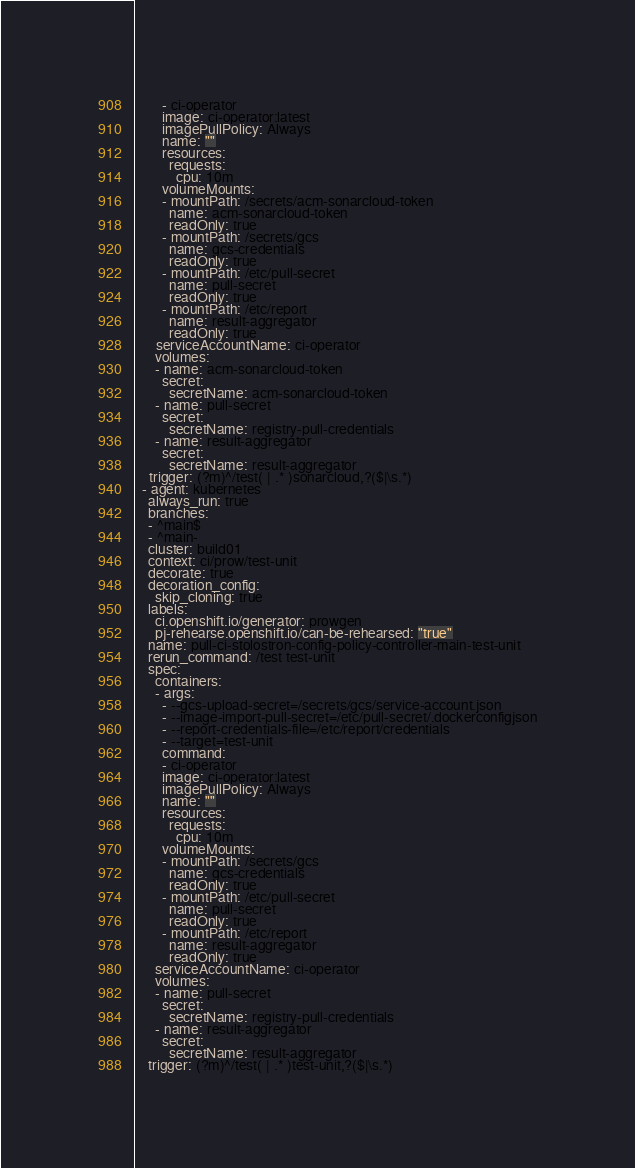<code> <loc_0><loc_0><loc_500><loc_500><_YAML_>        - ci-operator
        image: ci-operator:latest
        imagePullPolicy: Always
        name: ""
        resources:
          requests:
            cpu: 10m
        volumeMounts:
        - mountPath: /secrets/acm-sonarcloud-token
          name: acm-sonarcloud-token
          readOnly: true
        - mountPath: /secrets/gcs
          name: gcs-credentials
          readOnly: true
        - mountPath: /etc/pull-secret
          name: pull-secret
          readOnly: true
        - mountPath: /etc/report
          name: result-aggregator
          readOnly: true
      serviceAccountName: ci-operator
      volumes:
      - name: acm-sonarcloud-token
        secret:
          secretName: acm-sonarcloud-token
      - name: pull-secret
        secret:
          secretName: registry-pull-credentials
      - name: result-aggregator
        secret:
          secretName: result-aggregator
    trigger: (?m)^/test( | .* )sonarcloud,?($|\s.*)
  - agent: kubernetes
    always_run: true
    branches:
    - ^main$
    - ^main-
    cluster: build01
    context: ci/prow/test-unit
    decorate: true
    decoration_config:
      skip_cloning: true
    labels:
      ci.openshift.io/generator: prowgen
      pj-rehearse.openshift.io/can-be-rehearsed: "true"
    name: pull-ci-stolostron-config-policy-controller-main-test-unit
    rerun_command: /test test-unit
    spec:
      containers:
      - args:
        - --gcs-upload-secret=/secrets/gcs/service-account.json
        - --image-import-pull-secret=/etc/pull-secret/.dockerconfigjson
        - --report-credentials-file=/etc/report/credentials
        - --target=test-unit
        command:
        - ci-operator
        image: ci-operator:latest
        imagePullPolicy: Always
        name: ""
        resources:
          requests:
            cpu: 10m
        volumeMounts:
        - mountPath: /secrets/gcs
          name: gcs-credentials
          readOnly: true
        - mountPath: /etc/pull-secret
          name: pull-secret
          readOnly: true
        - mountPath: /etc/report
          name: result-aggregator
          readOnly: true
      serviceAccountName: ci-operator
      volumes:
      - name: pull-secret
        secret:
          secretName: registry-pull-credentials
      - name: result-aggregator
        secret:
          secretName: result-aggregator
    trigger: (?m)^/test( | .* )test-unit,?($|\s.*)
</code> 